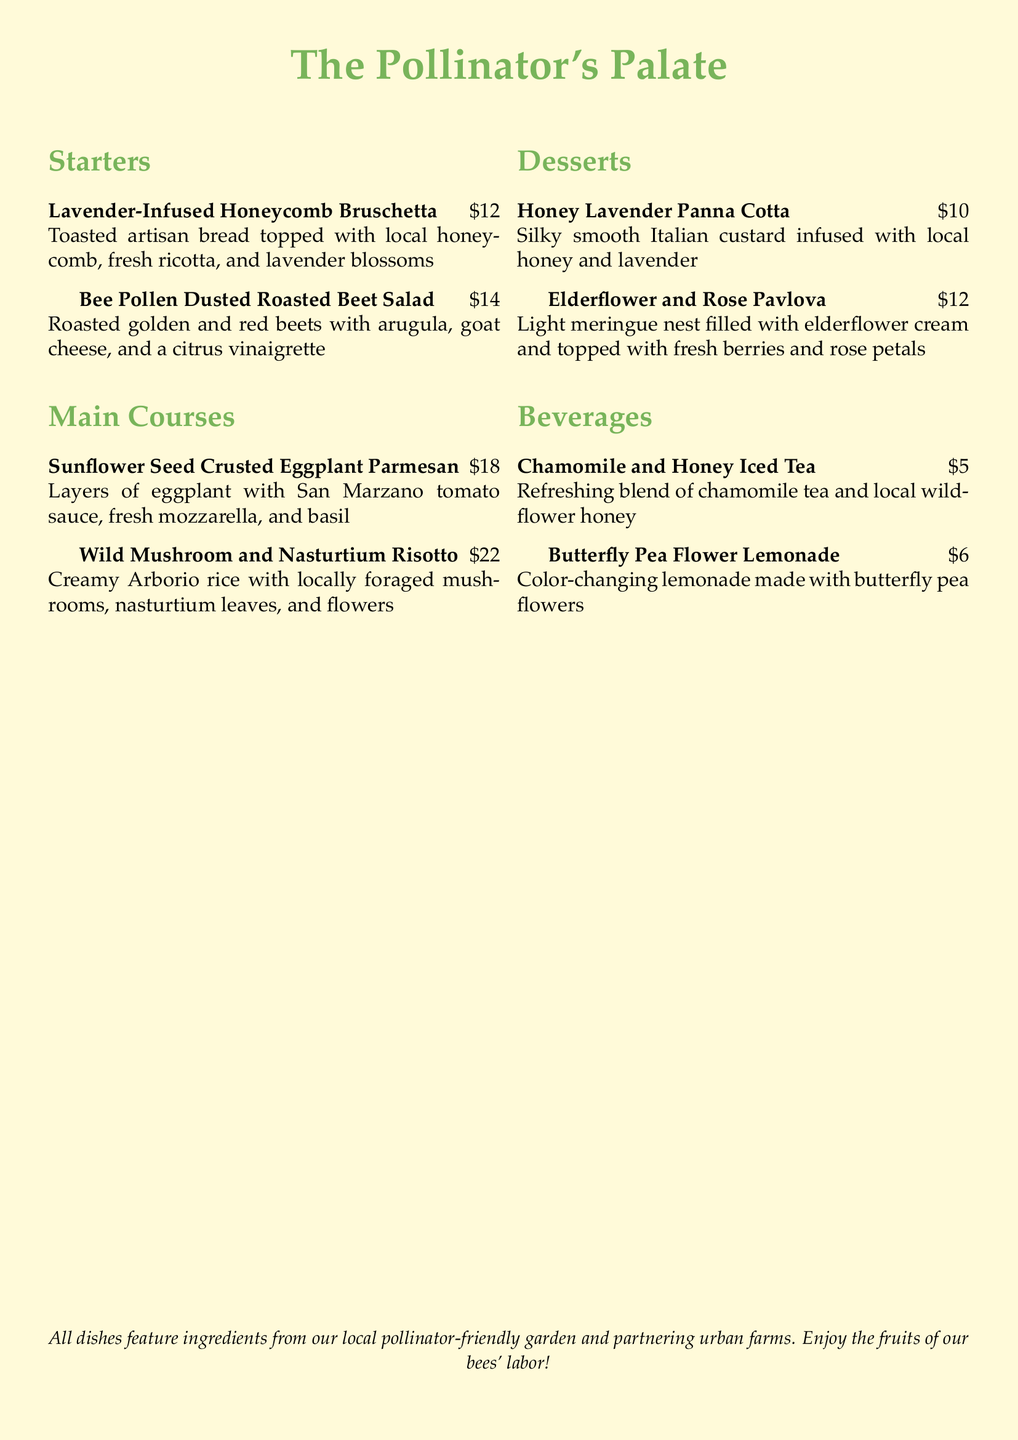what is the name of the first starter? The first starter listed is "Lavender-Infused Honeycomb Bruschetta."
Answer: Lavender-Infused Honeycomb Bruschetta how much does the Wild Mushroom and Nasturtium Risotto cost? The cost of the Wild Mushroom and Nasturtium Risotto is indicated in the menu.
Answer: $22 which dessert features rose petals? The dessert that includes rose petals is "Elderflower and Rose Pavlova."
Answer: Elderflower and Rose Pavlova what type of tea is in the Chamomile and Honey Iced Tea? The ingredient in the Chamomile and Honey Iced Tea is a blend of chamomile tea.
Answer: chamomile tea what is the common theme among the dishes? The menu indicates that all the dishes feature ingredients from a local pollinator-friendly garden.
Answer: pollinator-friendly ingredients count how many main courses are listed in the menu. The menu lists two main courses under the Main Courses section.
Answer: 2 what edible flower is used in the Wild Mushroom and Nasturtium Risotto? The edible flower included in the Wild Mushroom and Nasturtium Risotto is mentioned in the dish description.
Answer: nasturtium what beverage contains butterfly pea flowers? The beverage that contains butterfly pea flowers is "Butterfly Pea Flower Lemonade."
Answer: Butterfly Pea Flower Lemonade what is the overall theme of the menu? The menu's title and descriptions imply a focus on pollinator-friendly ingredients.
Answer: The Pollinator's Palate 